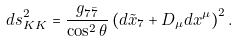Convert formula to latex. <formula><loc_0><loc_0><loc_500><loc_500>d s ^ { 2 } _ { K K } = \frac { g _ { 7 \bar { 7 } } } { \cos ^ { 2 } \theta } \left ( d \tilde { x } _ { 7 } + D _ { \mu } d x ^ { \mu } \right ) ^ { 2 } .</formula> 